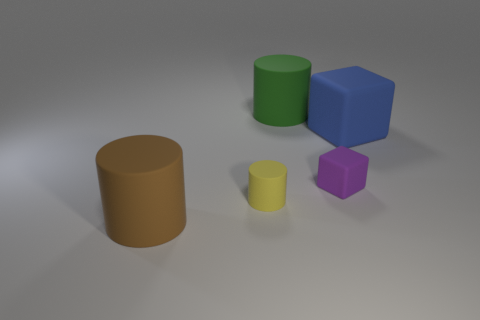Can you describe the lighting and shadows in the image? The image exhibits a soft, diffused lighting with the light source positioned to cast gentle shadows on the right side of the objects. The shadows are relatively soft-edged, suggesting the light source is not overly harsh and possibly diffused, creating a calm and neutral atmosphere. 